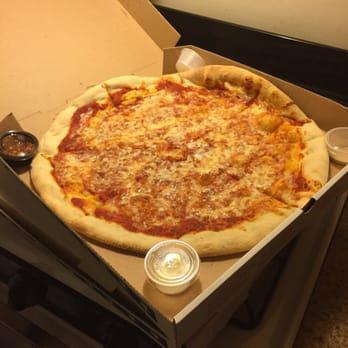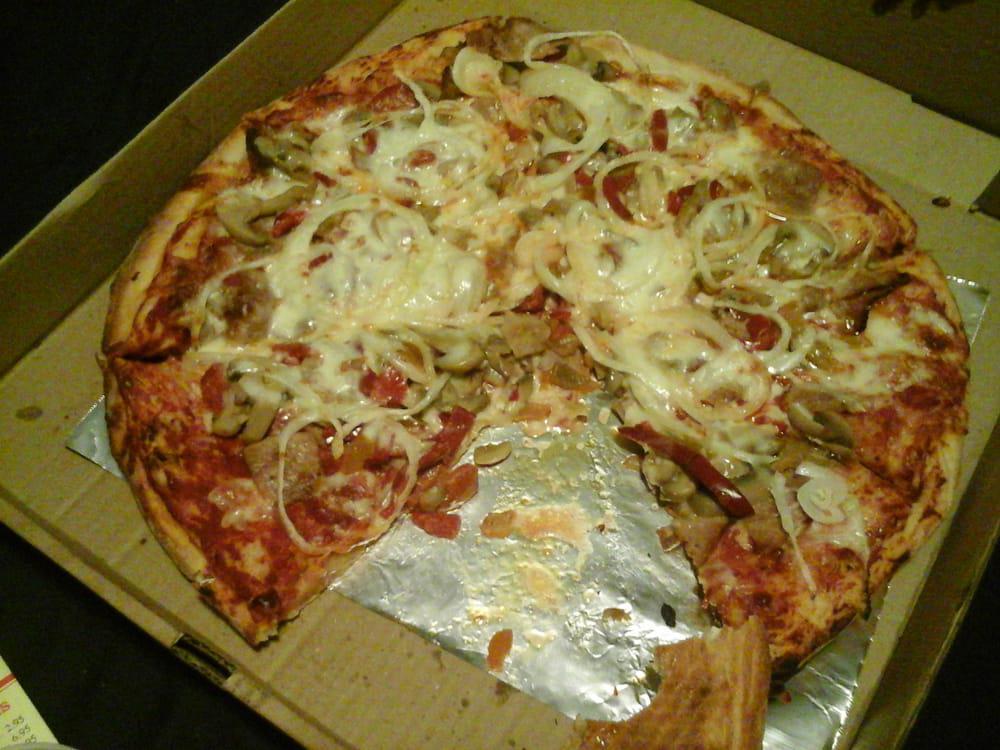The first image is the image on the left, the second image is the image on the right. Evaluate the accuracy of this statement regarding the images: "Each image contains one round pizza that is not in a box and does not have any slices missing.". Is it true? Answer yes or no. No. The first image is the image on the left, the second image is the image on the right. For the images displayed, is the sentence "The left and right image contains the same number of  uneaten pizzas." factually correct? Answer yes or no. No. 